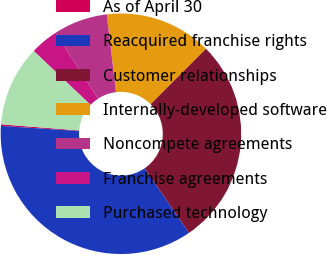<chart> <loc_0><loc_0><loc_500><loc_500><pie_chart><fcel>As of April 30<fcel>Reacquired franchise rights<fcel>Customer relationships<fcel>Internally-developed software<fcel>Noncompete agreements<fcel>Franchise agreements<fcel>Purchased technology<nl><fcel>0.21%<fcel>35.62%<fcel>27.94%<fcel>14.37%<fcel>7.29%<fcel>3.75%<fcel>10.83%<nl></chart> 